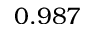<formula> <loc_0><loc_0><loc_500><loc_500>0 . 9 8 7</formula> 